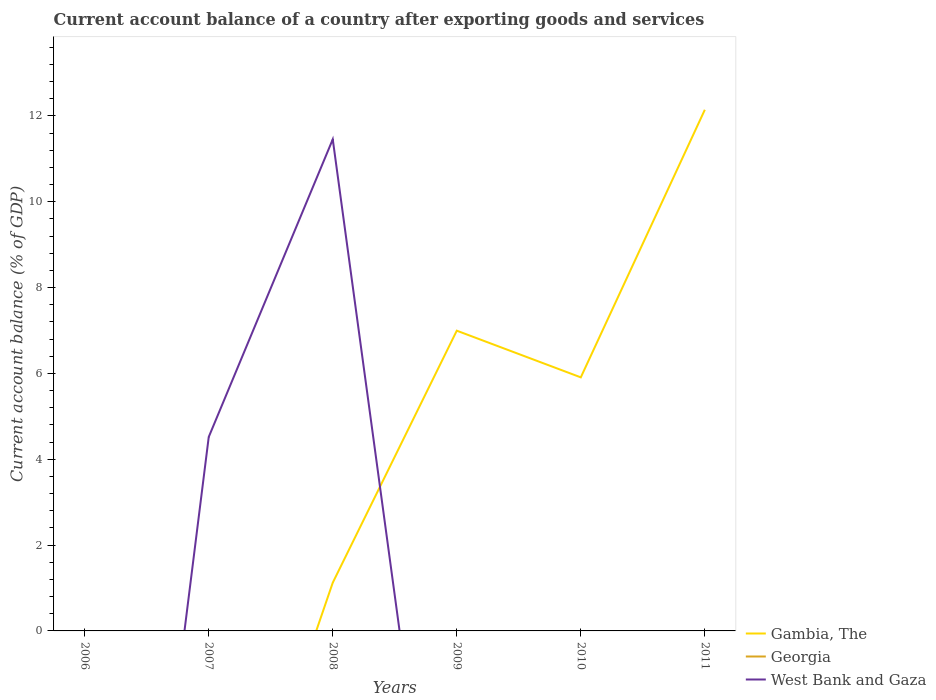How many different coloured lines are there?
Your answer should be compact. 2. Is the number of lines equal to the number of legend labels?
Offer a terse response. No. What is the total account balance in Gambia, The in the graph?
Provide a short and direct response. 1.09. What is the difference between the highest and the second highest account balance in West Bank and Gaza?
Provide a short and direct response. 11.45. How many lines are there?
Offer a terse response. 2. How many years are there in the graph?
Make the answer very short. 6. What is the difference between two consecutive major ticks on the Y-axis?
Your response must be concise. 2. Does the graph contain any zero values?
Provide a short and direct response. Yes. Does the graph contain grids?
Offer a terse response. No. How are the legend labels stacked?
Keep it short and to the point. Vertical. What is the title of the graph?
Your response must be concise. Current account balance of a country after exporting goods and services. Does "Caribbean small states" appear as one of the legend labels in the graph?
Your response must be concise. No. What is the label or title of the X-axis?
Offer a very short reply. Years. What is the label or title of the Y-axis?
Offer a terse response. Current account balance (% of GDP). What is the Current account balance (% of GDP) of Gambia, The in 2006?
Your answer should be very brief. 0. What is the Current account balance (% of GDP) in Georgia in 2006?
Ensure brevity in your answer.  0. What is the Current account balance (% of GDP) of Georgia in 2007?
Give a very brief answer. 0. What is the Current account balance (% of GDP) of West Bank and Gaza in 2007?
Your response must be concise. 4.52. What is the Current account balance (% of GDP) in Gambia, The in 2008?
Your answer should be very brief. 1.12. What is the Current account balance (% of GDP) in West Bank and Gaza in 2008?
Offer a very short reply. 11.45. What is the Current account balance (% of GDP) in Gambia, The in 2009?
Offer a very short reply. 6.99. What is the Current account balance (% of GDP) of Georgia in 2009?
Your answer should be compact. 0. What is the Current account balance (% of GDP) of West Bank and Gaza in 2009?
Provide a succinct answer. 0. What is the Current account balance (% of GDP) in Gambia, The in 2010?
Keep it short and to the point. 5.91. What is the Current account balance (% of GDP) in Georgia in 2010?
Make the answer very short. 0. What is the Current account balance (% of GDP) of Gambia, The in 2011?
Provide a short and direct response. 12.14. What is the Current account balance (% of GDP) in Georgia in 2011?
Ensure brevity in your answer.  0. What is the Current account balance (% of GDP) of West Bank and Gaza in 2011?
Offer a very short reply. 0. Across all years, what is the maximum Current account balance (% of GDP) in Gambia, The?
Offer a very short reply. 12.14. Across all years, what is the maximum Current account balance (% of GDP) in West Bank and Gaza?
Make the answer very short. 11.45. Across all years, what is the minimum Current account balance (% of GDP) in Gambia, The?
Give a very brief answer. 0. Across all years, what is the minimum Current account balance (% of GDP) in West Bank and Gaza?
Offer a terse response. 0. What is the total Current account balance (% of GDP) of Gambia, The in the graph?
Provide a succinct answer. 26.17. What is the total Current account balance (% of GDP) of West Bank and Gaza in the graph?
Your response must be concise. 15.97. What is the difference between the Current account balance (% of GDP) of West Bank and Gaza in 2007 and that in 2008?
Make the answer very short. -6.93. What is the difference between the Current account balance (% of GDP) in Gambia, The in 2008 and that in 2009?
Offer a very short reply. -5.87. What is the difference between the Current account balance (% of GDP) of Gambia, The in 2008 and that in 2010?
Keep it short and to the point. -4.78. What is the difference between the Current account balance (% of GDP) in Gambia, The in 2008 and that in 2011?
Make the answer very short. -11.02. What is the difference between the Current account balance (% of GDP) of Gambia, The in 2009 and that in 2010?
Provide a short and direct response. 1.09. What is the difference between the Current account balance (% of GDP) in Gambia, The in 2009 and that in 2011?
Give a very brief answer. -5.15. What is the difference between the Current account balance (% of GDP) of Gambia, The in 2010 and that in 2011?
Provide a short and direct response. -6.23. What is the average Current account balance (% of GDP) in Gambia, The per year?
Your response must be concise. 4.36. What is the average Current account balance (% of GDP) of Georgia per year?
Your response must be concise. 0. What is the average Current account balance (% of GDP) of West Bank and Gaza per year?
Provide a succinct answer. 2.66. In the year 2008, what is the difference between the Current account balance (% of GDP) of Gambia, The and Current account balance (% of GDP) of West Bank and Gaza?
Offer a terse response. -10.33. What is the ratio of the Current account balance (% of GDP) in West Bank and Gaza in 2007 to that in 2008?
Offer a very short reply. 0.39. What is the ratio of the Current account balance (% of GDP) of Gambia, The in 2008 to that in 2009?
Provide a short and direct response. 0.16. What is the ratio of the Current account balance (% of GDP) in Gambia, The in 2008 to that in 2010?
Make the answer very short. 0.19. What is the ratio of the Current account balance (% of GDP) in Gambia, The in 2008 to that in 2011?
Provide a succinct answer. 0.09. What is the ratio of the Current account balance (% of GDP) in Gambia, The in 2009 to that in 2010?
Make the answer very short. 1.18. What is the ratio of the Current account balance (% of GDP) in Gambia, The in 2009 to that in 2011?
Make the answer very short. 0.58. What is the ratio of the Current account balance (% of GDP) of Gambia, The in 2010 to that in 2011?
Give a very brief answer. 0.49. What is the difference between the highest and the second highest Current account balance (% of GDP) in Gambia, The?
Offer a terse response. 5.15. What is the difference between the highest and the lowest Current account balance (% of GDP) in Gambia, The?
Provide a short and direct response. 12.14. What is the difference between the highest and the lowest Current account balance (% of GDP) of West Bank and Gaza?
Offer a terse response. 11.45. 